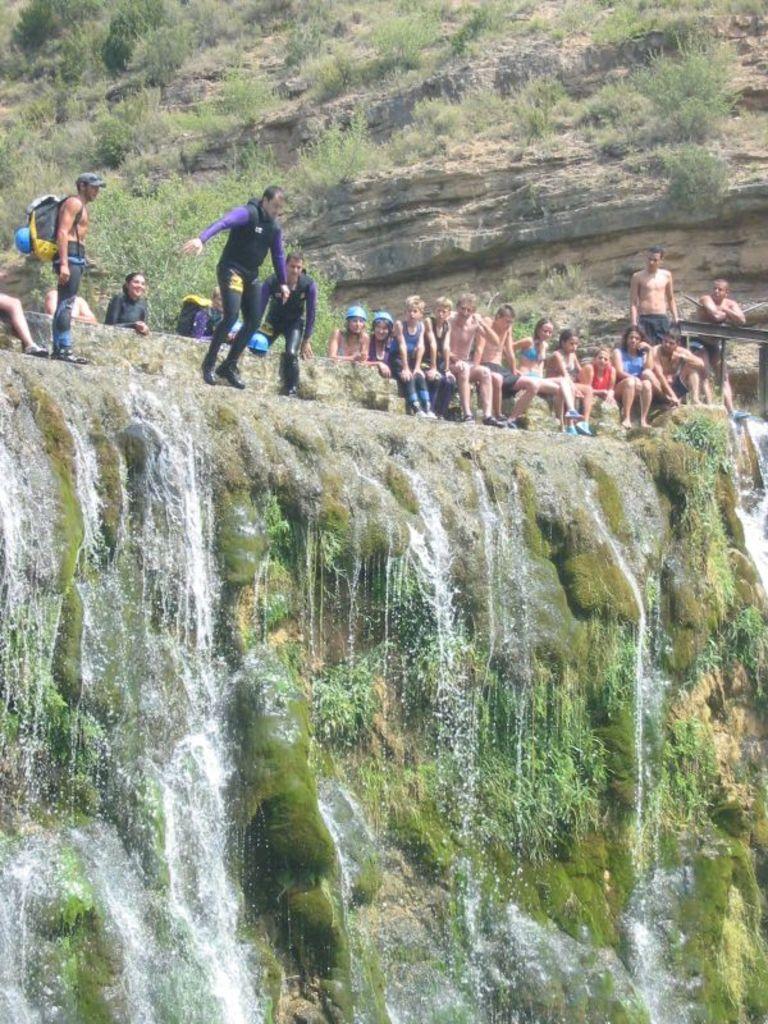How would you summarize this image in a sentence or two? In this image I can see few people are sitting on the rock. I can see the waterfall, green grass and a rock. 